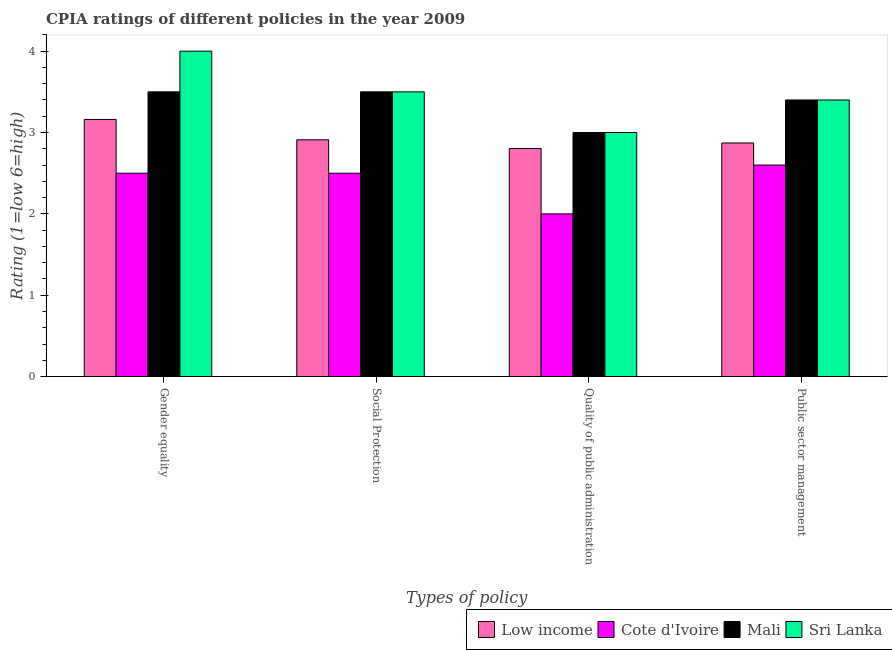Are the number of bars on each tick of the X-axis equal?
Provide a succinct answer. Yes. How many bars are there on the 2nd tick from the left?
Your answer should be compact. 4. What is the label of the 4th group of bars from the left?
Give a very brief answer. Public sector management. Across all countries, what is the minimum cpia rating of social protection?
Offer a very short reply. 2.5. In which country was the cpia rating of public sector management maximum?
Offer a very short reply. Mali. In which country was the cpia rating of gender equality minimum?
Give a very brief answer. Cote d'Ivoire. What is the total cpia rating of gender equality in the graph?
Make the answer very short. 13.16. What is the difference between the cpia rating of social protection in Mali and that in Cote d'Ivoire?
Keep it short and to the point. 1. What is the difference between the cpia rating of social protection in Low income and the cpia rating of public sector management in Sri Lanka?
Provide a succinct answer. -0.49. What is the average cpia rating of gender equality per country?
Provide a short and direct response. 3.29. What is the difference between the cpia rating of social protection and cpia rating of gender equality in Sri Lanka?
Provide a short and direct response. -0.5. In how many countries, is the cpia rating of social protection greater than 3 ?
Your response must be concise. 2. What is the ratio of the cpia rating of social protection in Sri Lanka to that in Mali?
Offer a very short reply. 1. What is the difference between the highest and the second highest cpia rating of public sector management?
Your answer should be compact. 0. What is the difference between the highest and the lowest cpia rating of social protection?
Ensure brevity in your answer.  1. In how many countries, is the cpia rating of social protection greater than the average cpia rating of social protection taken over all countries?
Offer a very short reply. 2. Is the sum of the cpia rating of gender equality in Sri Lanka and Mali greater than the maximum cpia rating of social protection across all countries?
Provide a succinct answer. Yes. What does the 3rd bar from the right in Gender equality represents?
Your answer should be very brief. Cote d'Ivoire. Is it the case that in every country, the sum of the cpia rating of gender equality and cpia rating of social protection is greater than the cpia rating of quality of public administration?
Ensure brevity in your answer.  Yes. Are all the bars in the graph horizontal?
Offer a very short reply. No. How many countries are there in the graph?
Offer a very short reply. 4. What is the difference between two consecutive major ticks on the Y-axis?
Provide a succinct answer. 1. Does the graph contain grids?
Keep it short and to the point. No. Where does the legend appear in the graph?
Provide a short and direct response. Bottom right. How are the legend labels stacked?
Ensure brevity in your answer.  Horizontal. What is the title of the graph?
Provide a succinct answer. CPIA ratings of different policies in the year 2009. What is the label or title of the X-axis?
Make the answer very short. Types of policy. What is the label or title of the Y-axis?
Keep it short and to the point. Rating (1=low 6=high). What is the Rating (1=low 6=high) of Low income in Gender equality?
Provide a succinct answer. 3.16. What is the Rating (1=low 6=high) of Cote d'Ivoire in Gender equality?
Offer a very short reply. 2.5. What is the Rating (1=low 6=high) of Low income in Social Protection?
Offer a terse response. 2.91. What is the Rating (1=low 6=high) in Mali in Social Protection?
Make the answer very short. 3.5. What is the Rating (1=low 6=high) in Sri Lanka in Social Protection?
Make the answer very short. 3.5. What is the Rating (1=low 6=high) of Low income in Quality of public administration?
Your response must be concise. 2.8. What is the Rating (1=low 6=high) in Mali in Quality of public administration?
Provide a short and direct response. 3. What is the Rating (1=low 6=high) in Low income in Public sector management?
Offer a very short reply. 2.87. What is the Rating (1=low 6=high) in Cote d'Ivoire in Public sector management?
Provide a short and direct response. 2.6. What is the Rating (1=low 6=high) in Mali in Public sector management?
Provide a succinct answer. 3.4. Across all Types of policy, what is the maximum Rating (1=low 6=high) in Low income?
Your answer should be compact. 3.16. Across all Types of policy, what is the maximum Rating (1=low 6=high) of Cote d'Ivoire?
Your answer should be compact. 2.6. Across all Types of policy, what is the maximum Rating (1=low 6=high) in Mali?
Give a very brief answer. 3.5. Across all Types of policy, what is the minimum Rating (1=low 6=high) in Low income?
Provide a succinct answer. 2.8. Across all Types of policy, what is the minimum Rating (1=low 6=high) in Mali?
Offer a very short reply. 3. What is the total Rating (1=low 6=high) of Low income in the graph?
Ensure brevity in your answer.  11.75. What is the total Rating (1=low 6=high) in Mali in the graph?
Ensure brevity in your answer.  13.4. What is the difference between the Rating (1=low 6=high) of Cote d'Ivoire in Gender equality and that in Social Protection?
Provide a succinct answer. 0. What is the difference between the Rating (1=low 6=high) in Mali in Gender equality and that in Social Protection?
Ensure brevity in your answer.  0. What is the difference between the Rating (1=low 6=high) in Low income in Gender equality and that in Quality of public administration?
Make the answer very short. 0.36. What is the difference between the Rating (1=low 6=high) of Cote d'Ivoire in Gender equality and that in Quality of public administration?
Keep it short and to the point. 0.5. What is the difference between the Rating (1=low 6=high) in Mali in Gender equality and that in Quality of public administration?
Ensure brevity in your answer.  0.5. What is the difference between the Rating (1=low 6=high) of Low income in Gender equality and that in Public sector management?
Offer a very short reply. 0.29. What is the difference between the Rating (1=low 6=high) of Cote d'Ivoire in Gender equality and that in Public sector management?
Keep it short and to the point. -0.1. What is the difference between the Rating (1=low 6=high) in Mali in Gender equality and that in Public sector management?
Your answer should be compact. 0.1. What is the difference between the Rating (1=low 6=high) in Sri Lanka in Gender equality and that in Public sector management?
Your answer should be very brief. 0.6. What is the difference between the Rating (1=low 6=high) in Low income in Social Protection and that in Quality of public administration?
Provide a succinct answer. 0.11. What is the difference between the Rating (1=low 6=high) in Cote d'Ivoire in Social Protection and that in Quality of public administration?
Make the answer very short. 0.5. What is the difference between the Rating (1=low 6=high) of Sri Lanka in Social Protection and that in Quality of public administration?
Give a very brief answer. 0.5. What is the difference between the Rating (1=low 6=high) of Low income in Social Protection and that in Public sector management?
Your answer should be compact. 0.04. What is the difference between the Rating (1=low 6=high) in Mali in Social Protection and that in Public sector management?
Ensure brevity in your answer.  0.1. What is the difference between the Rating (1=low 6=high) in Sri Lanka in Social Protection and that in Public sector management?
Give a very brief answer. 0.1. What is the difference between the Rating (1=low 6=high) in Low income in Quality of public administration and that in Public sector management?
Offer a very short reply. -0.07. What is the difference between the Rating (1=low 6=high) in Cote d'Ivoire in Quality of public administration and that in Public sector management?
Give a very brief answer. -0.6. What is the difference between the Rating (1=low 6=high) in Mali in Quality of public administration and that in Public sector management?
Give a very brief answer. -0.4. What is the difference between the Rating (1=low 6=high) of Low income in Gender equality and the Rating (1=low 6=high) of Cote d'Ivoire in Social Protection?
Your answer should be very brief. 0.66. What is the difference between the Rating (1=low 6=high) in Low income in Gender equality and the Rating (1=low 6=high) in Mali in Social Protection?
Your answer should be compact. -0.34. What is the difference between the Rating (1=low 6=high) of Low income in Gender equality and the Rating (1=low 6=high) of Sri Lanka in Social Protection?
Offer a very short reply. -0.34. What is the difference between the Rating (1=low 6=high) of Cote d'Ivoire in Gender equality and the Rating (1=low 6=high) of Sri Lanka in Social Protection?
Offer a terse response. -1. What is the difference between the Rating (1=low 6=high) of Low income in Gender equality and the Rating (1=low 6=high) of Cote d'Ivoire in Quality of public administration?
Keep it short and to the point. 1.16. What is the difference between the Rating (1=low 6=high) of Low income in Gender equality and the Rating (1=low 6=high) of Mali in Quality of public administration?
Provide a short and direct response. 0.16. What is the difference between the Rating (1=low 6=high) of Low income in Gender equality and the Rating (1=low 6=high) of Sri Lanka in Quality of public administration?
Make the answer very short. 0.16. What is the difference between the Rating (1=low 6=high) of Cote d'Ivoire in Gender equality and the Rating (1=low 6=high) of Mali in Quality of public administration?
Your response must be concise. -0.5. What is the difference between the Rating (1=low 6=high) in Low income in Gender equality and the Rating (1=low 6=high) in Cote d'Ivoire in Public sector management?
Offer a very short reply. 0.56. What is the difference between the Rating (1=low 6=high) in Low income in Gender equality and the Rating (1=low 6=high) in Mali in Public sector management?
Keep it short and to the point. -0.24. What is the difference between the Rating (1=low 6=high) in Low income in Gender equality and the Rating (1=low 6=high) in Sri Lanka in Public sector management?
Keep it short and to the point. -0.24. What is the difference between the Rating (1=low 6=high) in Cote d'Ivoire in Gender equality and the Rating (1=low 6=high) in Sri Lanka in Public sector management?
Your answer should be very brief. -0.9. What is the difference between the Rating (1=low 6=high) of Low income in Social Protection and the Rating (1=low 6=high) of Cote d'Ivoire in Quality of public administration?
Offer a terse response. 0.91. What is the difference between the Rating (1=low 6=high) in Low income in Social Protection and the Rating (1=low 6=high) in Mali in Quality of public administration?
Offer a very short reply. -0.09. What is the difference between the Rating (1=low 6=high) of Low income in Social Protection and the Rating (1=low 6=high) of Sri Lanka in Quality of public administration?
Your answer should be very brief. -0.09. What is the difference between the Rating (1=low 6=high) of Mali in Social Protection and the Rating (1=low 6=high) of Sri Lanka in Quality of public administration?
Provide a succinct answer. 0.5. What is the difference between the Rating (1=low 6=high) in Low income in Social Protection and the Rating (1=low 6=high) in Cote d'Ivoire in Public sector management?
Provide a short and direct response. 0.31. What is the difference between the Rating (1=low 6=high) of Low income in Social Protection and the Rating (1=low 6=high) of Mali in Public sector management?
Your answer should be very brief. -0.49. What is the difference between the Rating (1=low 6=high) of Low income in Social Protection and the Rating (1=low 6=high) of Sri Lanka in Public sector management?
Your answer should be very brief. -0.49. What is the difference between the Rating (1=low 6=high) of Low income in Quality of public administration and the Rating (1=low 6=high) of Cote d'Ivoire in Public sector management?
Ensure brevity in your answer.  0.2. What is the difference between the Rating (1=low 6=high) in Low income in Quality of public administration and the Rating (1=low 6=high) in Mali in Public sector management?
Provide a succinct answer. -0.6. What is the difference between the Rating (1=low 6=high) in Low income in Quality of public administration and the Rating (1=low 6=high) in Sri Lanka in Public sector management?
Keep it short and to the point. -0.6. What is the difference between the Rating (1=low 6=high) of Cote d'Ivoire in Quality of public administration and the Rating (1=low 6=high) of Mali in Public sector management?
Keep it short and to the point. -1.4. What is the average Rating (1=low 6=high) in Low income per Types of policy?
Offer a terse response. 2.94. What is the average Rating (1=low 6=high) of Cote d'Ivoire per Types of policy?
Offer a very short reply. 2.4. What is the average Rating (1=low 6=high) of Mali per Types of policy?
Your answer should be compact. 3.35. What is the average Rating (1=low 6=high) of Sri Lanka per Types of policy?
Give a very brief answer. 3.48. What is the difference between the Rating (1=low 6=high) of Low income and Rating (1=low 6=high) of Cote d'Ivoire in Gender equality?
Offer a terse response. 0.66. What is the difference between the Rating (1=low 6=high) of Low income and Rating (1=low 6=high) of Mali in Gender equality?
Give a very brief answer. -0.34. What is the difference between the Rating (1=low 6=high) of Low income and Rating (1=low 6=high) of Sri Lanka in Gender equality?
Make the answer very short. -0.84. What is the difference between the Rating (1=low 6=high) of Cote d'Ivoire and Rating (1=low 6=high) of Mali in Gender equality?
Keep it short and to the point. -1. What is the difference between the Rating (1=low 6=high) of Mali and Rating (1=low 6=high) of Sri Lanka in Gender equality?
Give a very brief answer. -0.5. What is the difference between the Rating (1=low 6=high) in Low income and Rating (1=low 6=high) in Cote d'Ivoire in Social Protection?
Keep it short and to the point. 0.41. What is the difference between the Rating (1=low 6=high) in Low income and Rating (1=low 6=high) in Mali in Social Protection?
Provide a succinct answer. -0.59. What is the difference between the Rating (1=low 6=high) in Low income and Rating (1=low 6=high) in Sri Lanka in Social Protection?
Your answer should be very brief. -0.59. What is the difference between the Rating (1=low 6=high) of Cote d'Ivoire and Rating (1=low 6=high) of Sri Lanka in Social Protection?
Keep it short and to the point. -1. What is the difference between the Rating (1=low 6=high) of Low income and Rating (1=low 6=high) of Cote d'Ivoire in Quality of public administration?
Make the answer very short. 0.8. What is the difference between the Rating (1=low 6=high) in Low income and Rating (1=low 6=high) in Mali in Quality of public administration?
Offer a very short reply. -0.2. What is the difference between the Rating (1=low 6=high) in Low income and Rating (1=low 6=high) in Sri Lanka in Quality of public administration?
Ensure brevity in your answer.  -0.2. What is the difference between the Rating (1=low 6=high) of Cote d'Ivoire and Rating (1=low 6=high) of Mali in Quality of public administration?
Offer a terse response. -1. What is the difference between the Rating (1=low 6=high) in Cote d'Ivoire and Rating (1=low 6=high) in Sri Lanka in Quality of public administration?
Keep it short and to the point. -1. What is the difference between the Rating (1=low 6=high) in Low income and Rating (1=low 6=high) in Cote d'Ivoire in Public sector management?
Keep it short and to the point. 0.27. What is the difference between the Rating (1=low 6=high) in Low income and Rating (1=low 6=high) in Mali in Public sector management?
Offer a terse response. -0.53. What is the difference between the Rating (1=low 6=high) in Low income and Rating (1=low 6=high) in Sri Lanka in Public sector management?
Provide a succinct answer. -0.53. What is the difference between the Rating (1=low 6=high) of Cote d'Ivoire and Rating (1=low 6=high) of Mali in Public sector management?
Offer a very short reply. -0.8. What is the ratio of the Rating (1=low 6=high) in Low income in Gender equality to that in Social Protection?
Offer a terse response. 1.09. What is the ratio of the Rating (1=low 6=high) of Mali in Gender equality to that in Social Protection?
Your answer should be compact. 1. What is the ratio of the Rating (1=low 6=high) in Sri Lanka in Gender equality to that in Social Protection?
Your answer should be compact. 1.14. What is the ratio of the Rating (1=low 6=high) of Low income in Gender equality to that in Quality of public administration?
Give a very brief answer. 1.13. What is the ratio of the Rating (1=low 6=high) of Sri Lanka in Gender equality to that in Quality of public administration?
Provide a succinct answer. 1.33. What is the ratio of the Rating (1=low 6=high) of Low income in Gender equality to that in Public sector management?
Your response must be concise. 1.1. What is the ratio of the Rating (1=low 6=high) of Cote d'Ivoire in Gender equality to that in Public sector management?
Provide a short and direct response. 0.96. What is the ratio of the Rating (1=low 6=high) in Mali in Gender equality to that in Public sector management?
Give a very brief answer. 1.03. What is the ratio of the Rating (1=low 6=high) in Sri Lanka in Gender equality to that in Public sector management?
Ensure brevity in your answer.  1.18. What is the ratio of the Rating (1=low 6=high) of Low income in Social Protection to that in Quality of public administration?
Provide a succinct answer. 1.04. What is the ratio of the Rating (1=low 6=high) in Mali in Social Protection to that in Quality of public administration?
Offer a terse response. 1.17. What is the ratio of the Rating (1=low 6=high) of Low income in Social Protection to that in Public sector management?
Make the answer very short. 1.01. What is the ratio of the Rating (1=low 6=high) of Cote d'Ivoire in Social Protection to that in Public sector management?
Provide a succinct answer. 0.96. What is the ratio of the Rating (1=low 6=high) of Mali in Social Protection to that in Public sector management?
Provide a succinct answer. 1.03. What is the ratio of the Rating (1=low 6=high) of Sri Lanka in Social Protection to that in Public sector management?
Your answer should be very brief. 1.03. What is the ratio of the Rating (1=low 6=high) in Low income in Quality of public administration to that in Public sector management?
Provide a short and direct response. 0.98. What is the ratio of the Rating (1=low 6=high) of Cote d'Ivoire in Quality of public administration to that in Public sector management?
Your answer should be compact. 0.77. What is the ratio of the Rating (1=low 6=high) of Mali in Quality of public administration to that in Public sector management?
Ensure brevity in your answer.  0.88. What is the ratio of the Rating (1=low 6=high) of Sri Lanka in Quality of public administration to that in Public sector management?
Keep it short and to the point. 0.88. What is the difference between the highest and the second highest Rating (1=low 6=high) of Low income?
Make the answer very short. 0.25. What is the difference between the highest and the second highest Rating (1=low 6=high) in Cote d'Ivoire?
Your response must be concise. 0.1. What is the difference between the highest and the second highest Rating (1=low 6=high) in Mali?
Offer a very short reply. 0. What is the difference between the highest and the second highest Rating (1=low 6=high) of Sri Lanka?
Provide a short and direct response. 0.5. What is the difference between the highest and the lowest Rating (1=low 6=high) in Low income?
Your answer should be compact. 0.36. What is the difference between the highest and the lowest Rating (1=low 6=high) in Cote d'Ivoire?
Make the answer very short. 0.6. What is the difference between the highest and the lowest Rating (1=low 6=high) in Mali?
Your response must be concise. 0.5. 